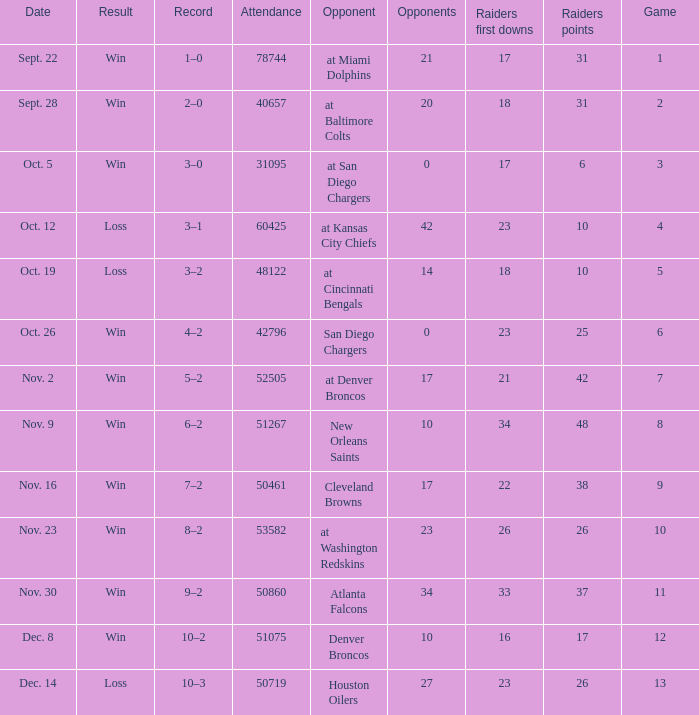Who was the game attended by 60425 people played against? At kansas city chiefs. 